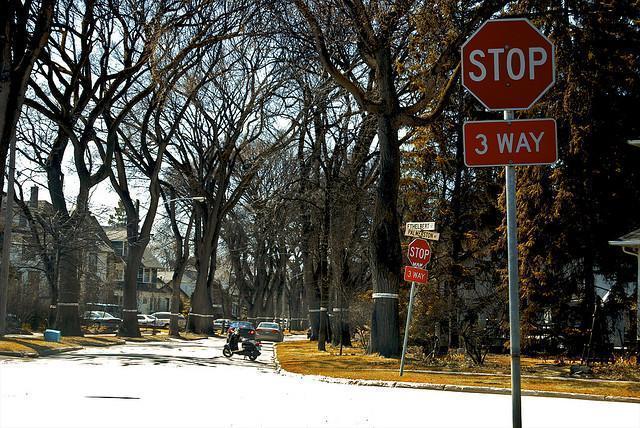How many stop signs are in the picture?
Give a very brief answer. 2. 